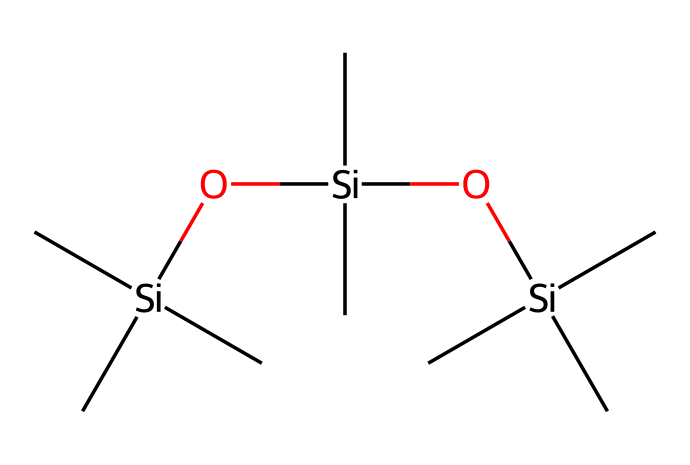What is the main type of atoms present in this chemical structure? The SMILES representation shows silicon (Si) and carbon (C) atoms as the main components of the molecular structure. There are no other types of atoms visible in the SMILES notation.
Answer: silicon and carbon How many silicon atoms are in the structure? By analyzing the SMILES notation, we can see that there are three instances of 'Si' present in the molecular arrangement, indicating there are three silicon atoms.
Answer: three What type of chemical is this compound classified as? The structure consists of siloxane bonds (Si-O) and hydrocarbons, which characterizes it as a type of lubricant known as dielectric grease.
Answer: dielectric grease Based on the structure, does this compound likely have a high or low dielectric strength? The presence of multiple silicon-oxygen bonds and a long carbon chain suggests a high dielectric strength due to the insulating properties of siloxanes, which are known for their dielectric stability.
Answer: high What characteristic does the presence of multiple silicon atoms provide to lubricants? Multiple silicon atoms in lubricants such as dielectric greases contribute to their ability to withstand high temperatures and resist electrical breakdown, which is essential in high-voltage applications like alarm systems.
Answer: thermal stability What kind of functional groups can be identified in this chemical structure? The SMILES representation includes siloxane (-Si-O-Si-) functional groups, which are typical in silicone-based compounds like dielectric greases, and contribute to their lubricating properties.
Answer: siloxane How does the molecular arrangement affect the viscosity of this lubricant? The branched structure with multiple silicon and carbon chains allows for a flexible arrangement, leading to lower viscosity, which is a desired property in lubricants to ensure ease of application and compatibility with high-voltage environments.
Answer: lower viscosity 